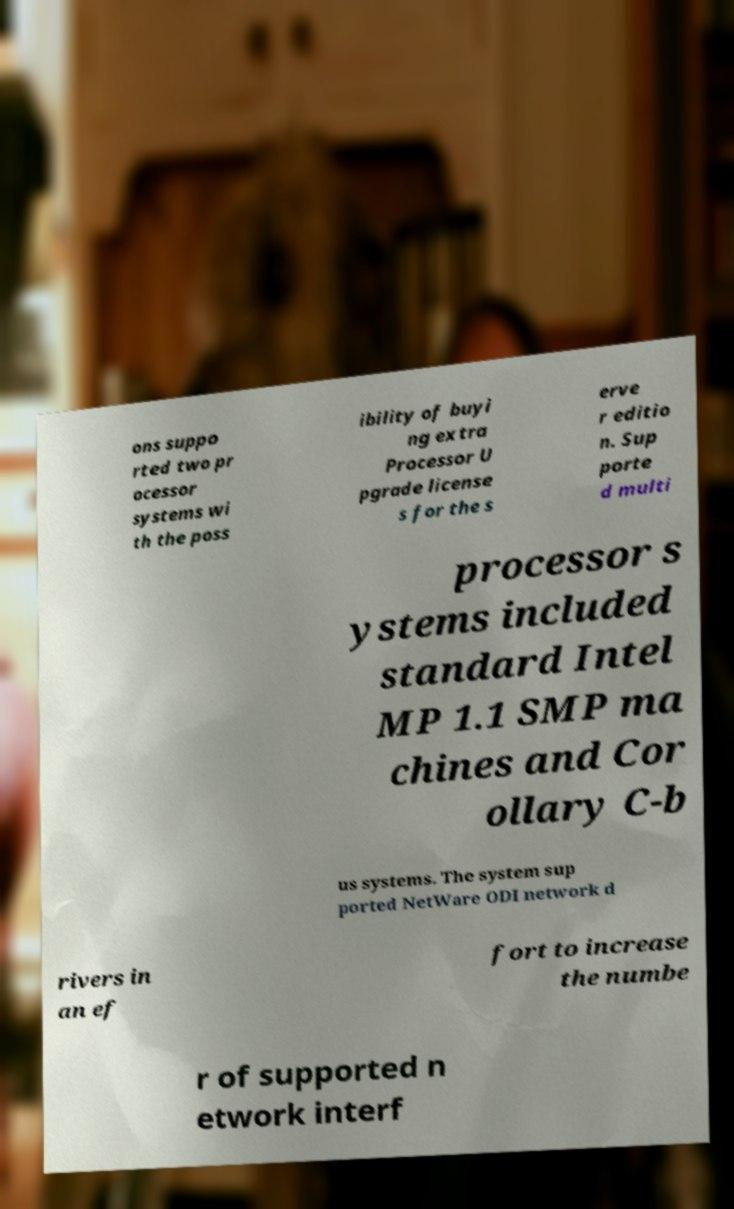Could you extract and type out the text from this image? ons suppo rted two pr ocessor systems wi th the poss ibility of buyi ng extra Processor U pgrade license s for the s erve r editio n. Sup porte d multi processor s ystems included standard Intel MP 1.1 SMP ma chines and Cor ollary C-b us systems. The system sup ported NetWare ODI network d rivers in an ef fort to increase the numbe r of supported n etwork interf 